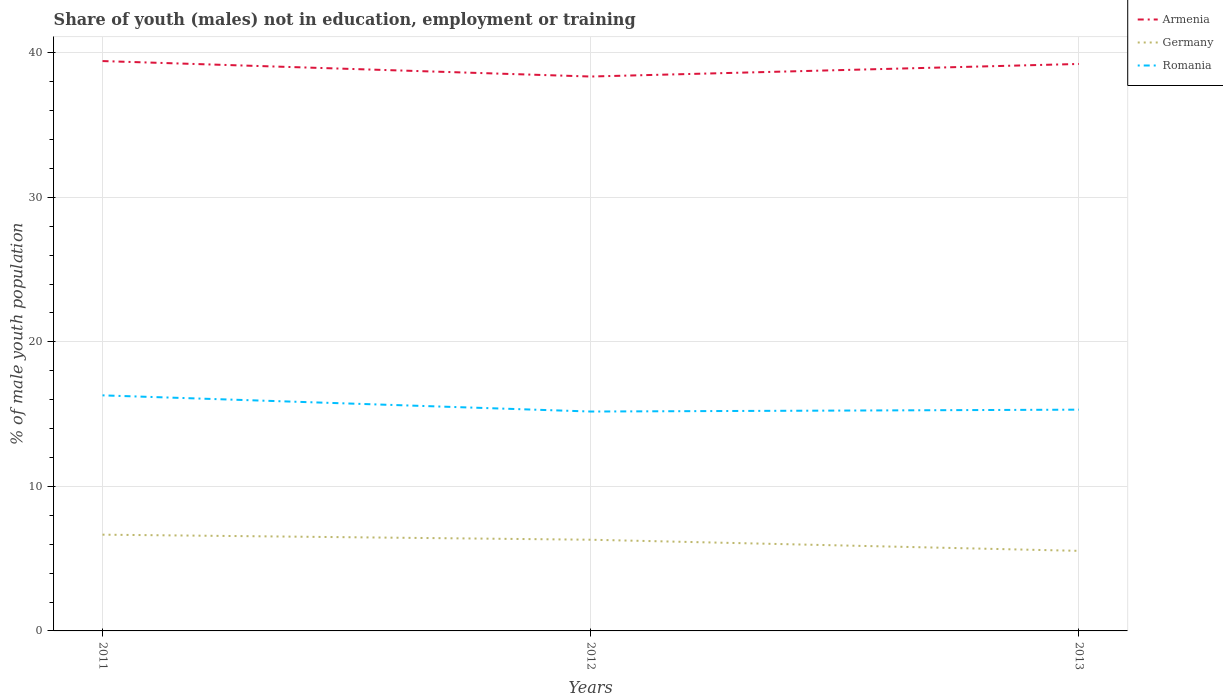How many different coloured lines are there?
Provide a short and direct response. 3. Does the line corresponding to Armenia intersect with the line corresponding to Germany?
Offer a terse response. No. Is the number of lines equal to the number of legend labels?
Make the answer very short. Yes. Across all years, what is the maximum percentage of unemployed males population in in Germany?
Make the answer very short. 5.54. In which year was the percentage of unemployed males population in in Germany maximum?
Keep it short and to the point. 2013. What is the total percentage of unemployed males population in in Armenia in the graph?
Ensure brevity in your answer.  0.2. What is the difference between the highest and the second highest percentage of unemployed males population in in Germany?
Offer a very short reply. 1.12. How many years are there in the graph?
Your answer should be very brief. 3. What is the difference between two consecutive major ticks on the Y-axis?
Provide a succinct answer. 10. Does the graph contain any zero values?
Your response must be concise. No. How many legend labels are there?
Provide a succinct answer. 3. How are the legend labels stacked?
Provide a short and direct response. Vertical. What is the title of the graph?
Your response must be concise. Share of youth (males) not in education, employment or training. What is the label or title of the Y-axis?
Offer a terse response. % of male youth population. What is the % of male youth population of Armenia in 2011?
Your response must be concise. 39.43. What is the % of male youth population in Germany in 2011?
Provide a succinct answer. 6.66. What is the % of male youth population of Romania in 2011?
Offer a terse response. 16.3. What is the % of male youth population of Armenia in 2012?
Your answer should be compact. 38.36. What is the % of male youth population of Germany in 2012?
Offer a very short reply. 6.31. What is the % of male youth population in Romania in 2012?
Your response must be concise. 15.18. What is the % of male youth population of Armenia in 2013?
Provide a short and direct response. 39.23. What is the % of male youth population in Germany in 2013?
Your response must be concise. 5.54. What is the % of male youth population of Romania in 2013?
Provide a short and direct response. 15.31. Across all years, what is the maximum % of male youth population in Armenia?
Offer a terse response. 39.43. Across all years, what is the maximum % of male youth population of Germany?
Offer a terse response. 6.66. Across all years, what is the maximum % of male youth population in Romania?
Provide a short and direct response. 16.3. Across all years, what is the minimum % of male youth population in Armenia?
Your answer should be very brief. 38.36. Across all years, what is the minimum % of male youth population in Germany?
Give a very brief answer. 5.54. Across all years, what is the minimum % of male youth population in Romania?
Keep it short and to the point. 15.18. What is the total % of male youth population of Armenia in the graph?
Make the answer very short. 117.02. What is the total % of male youth population of Germany in the graph?
Your response must be concise. 18.51. What is the total % of male youth population of Romania in the graph?
Your response must be concise. 46.79. What is the difference between the % of male youth population of Armenia in 2011 and that in 2012?
Ensure brevity in your answer.  1.07. What is the difference between the % of male youth population in Romania in 2011 and that in 2012?
Keep it short and to the point. 1.12. What is the difference between the % of male youth population of Germany in 2011 and that in 2013?
Make the answer very short. 1.12. What is the difference between the % of male youth population of Romania in 2011 and that in 2013?
Provide a short and direct response. 0.99. What is the difference between the % of male youth population in Armenia in 2012 and that in 2013?
Offer a terse response. -0.87. What is the difference between the % of male youth population in Germany in 2012 and that in 2013?
Your response must be concise. 0.77. What is the difference between the % of male youth population of Romania in 2012 and that in 2013?
Ensure brevity in your answer.  -0.13. What is the difference between the % of male youth population of Armenia in 2011 and the % of male youth population of Germany in 2012?
Offer a terse response. 33.12. What is the difference between the % of male youth population of Armenia in 2011 and the % of male youth population of Romania in 2012?
Keep it short and to the point. 24.25. What is the difference between the % of male youth population of Germany in 2011 and the % of male youth population of Romania in 2012?
Provide a short and direct response. -8.52. What is the difference between the % of male youth population in Armenia in 2011 and the % of male youth population in Germany in 2013?
Provide a short and direct response. 33.89. What is the difference between the % of male youth population in Armenia in 2011 and the % of male youth population in Romania in 2013?
Your answer should be very brief. 24.12. What is the difference between the % of male youth population in Germany in 2011 and the % of male youth population in Romania in 2013?
Your response must be concise. -8.65. What is the difference between the % of male youth population of Armenia in 2012 and the % of male youth population of Germany in 2013?
Keep it short and to the point. 32.82. What is the difference between the % of male youth population in Armenia in 2012 and the % of male youth population in Romania in 2013?
Offer a very short reply. 23.05. What is the difference between the % of male youth population of Germany in 2012 and the % of male youth population of Romania in 2013?
Offer a terse response. -9. What is the average % of male youth population of Armenia per year?
Ensure brevity in your answer.  39.01. What is the average % of male youth population in Germany per year?
Your answer should be very brief. 6.17. What is the average % of male youth population in Romania per year?
Provide a succinct answer. 15.6. In the year 2011, what is the difference between the % of male youth population in Armenia and % of male youth population in Germany?
Ensure brevity in your answer.  32.77. In the year 2011, what is the difference between the % of male youth population of Armenia and % of male youth population of Romania?
Provide a short and direct response. 23.13. In the year 2011, what is the difference between the % of male youth population of Germany and % of male youth population of Romania?
Keep it short and to the point. -9.64. In the year 2012, what is the difference between the % of male youth population of Armenia and % of male youth population of Germany?
Offer a terse response. 32.05. In the year 2012, what is the difference between the % of male youth population of Armenia and % of male youth population of Romania?
Ensure brevity in your answer.  23.18. In the year 2012, what is the difference between the % of male youth population in Germany and % of male youth population in Romania?
Your answer should be very brief. -8.87. In the year 2013, what is the difference between the % of male youth population of Armenia and % of male youth population of Germany?
Offer a terse response. 33.69. In the year 2013, what is the difference between the % of male youth population in Armenia and % of male youth population in Romania?
Provide a succinct answer. 23.92. In the year 2013, what is the difference between the % of male youth population in Germany and % of male youth population in Romania?
Give a very brief answer. -9.77. What is the ratio of the % of male youth population of Armenia in 2011 to that in 2012?
Your answer should be compact. 1.03. What is the ratio of the % of male youth population of Germany in 2011 to that in 2012?
Make the answer very short. 1.06. What is the ratio of the % of male youth population in Romania in 2011 to that in 2012?
Offer a very short reply. 1.07. What is the ratio of the % of male youth population of Armenia in 2011 to that in 2013?
Give a very brief answer. 1.01. What is the ratio of the % of male youth population in Germany in 2011 to that in 2013?
Offer a terse response. 1.2. What is the ratio of the % of male youth population of Romania in 2011 to that in 2013?
Offer a terse response. 1.06. What is the ratio of the % of male youth population in Armenia in 2012 to that in 2013?
Your answer should be compact. 0.98. What is the ratio of the % of male youth population of Germany in 2012 to that in 2013?
Make the answer very short. 1.14. What is the difference between the highest and the second highest % of male youth population in Armenia?
Your response must be concise. 0.2. What is the difference between the highest and the second highest % of male youth population of Romania?
Provide a short and direct response. 0.99. What is the difference between the highest and the lowest % of male youth population in Armenia?
Provide a succinct answer. 1.07. What is the difference between the highest and the lowest % of male youth population in Germany?
Provide a succinct answer. 1.12. What is the difference between the highest and the lowest % of male youth population in Romania?
Keep it short and to the point. 1.12. 